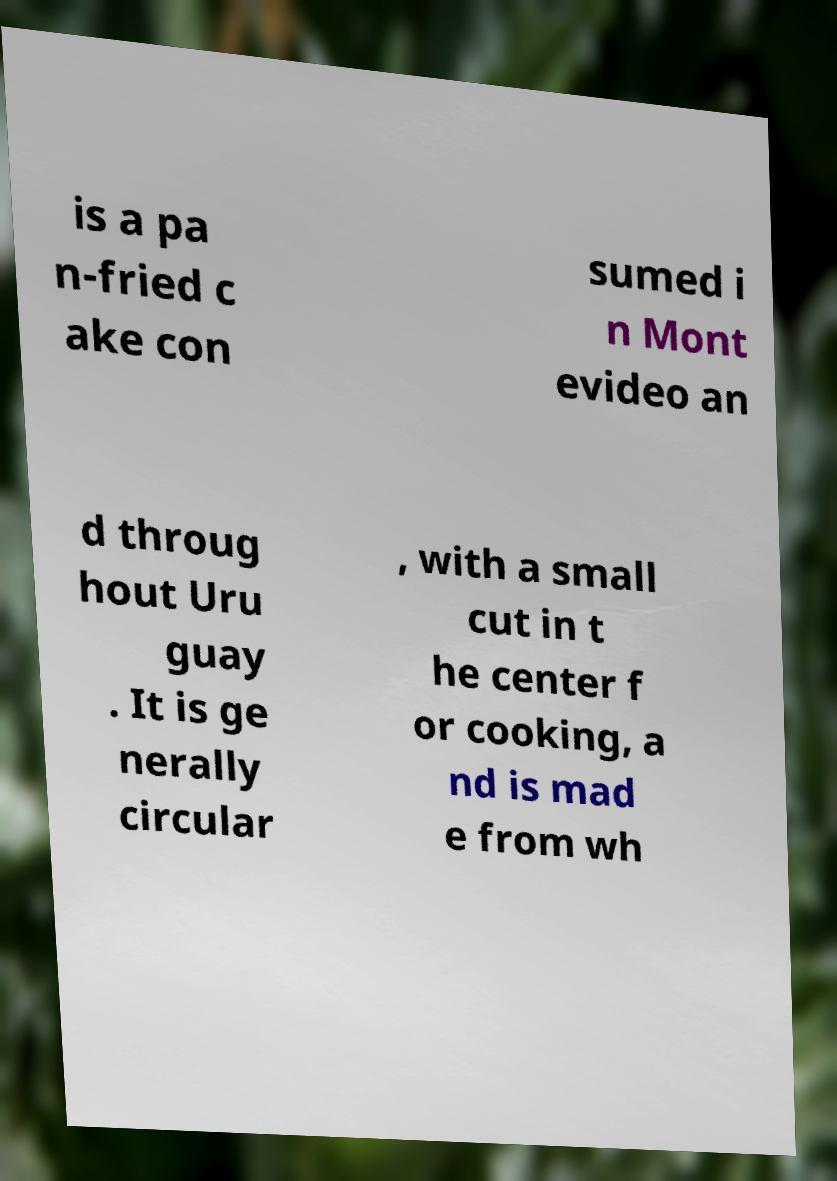I need the written content from this picture converted into text. Can you do that? is a pa n-fried c ake con sumed i n Mont evideo an d throug hout Uru guay . It is ge nerally circular , with a small cut in t he center f or cooking, a nd is mad e from wh 